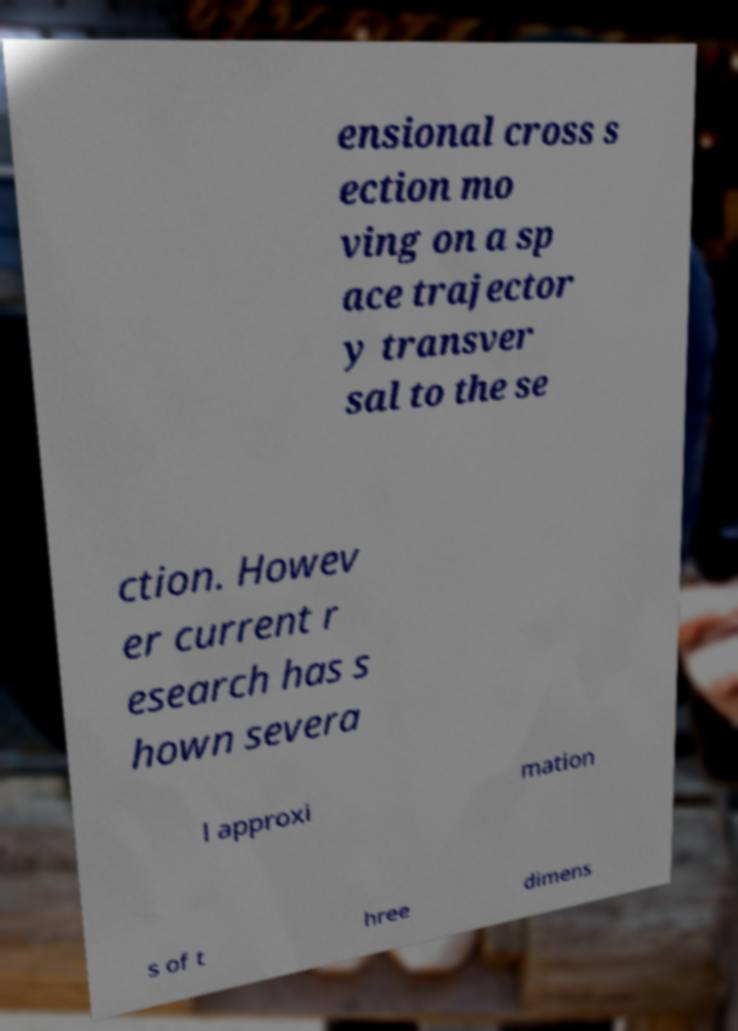I need the written content from this picture converted into text. Can you do that? ensional cross s ection mo ving on a sp ace trajector y transver sal to the se ction. Howev er current r esearch has s hown severa l approxi mation s of t hree dimens 